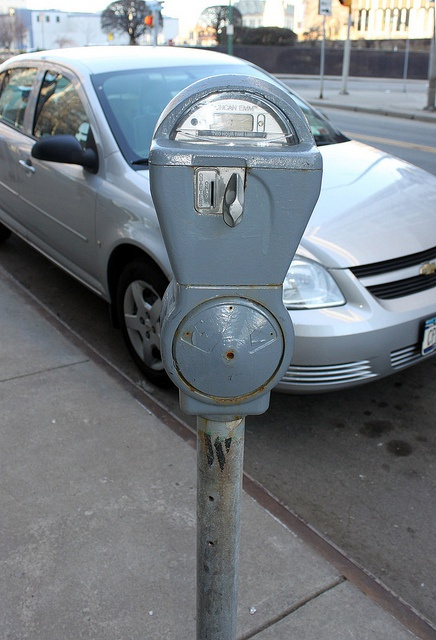Describe the objects in this image and their specific colors. I can see car in white, lightgray, gray, black, and lightblue tones, parking meter in white, gray, and darkgray tones, traffic light in white, orange, salmon, gray, and darkgray tones, and traffic light in white, maroon, red, and tan tones in this image. 